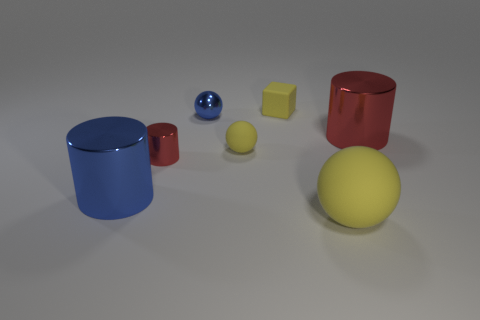Subtract all matte balls. How many balls are left? 1 Add 1 matte cubes. How many objects exist? 8 Subtract all yellow balls. How many balls are left? 1 Add 7 large yellow metal blocks. How many large yellow metal blocks exist? 7 Subtract 0 purple blocks. How many objects are left? 7 Subtract all spheres. How many objects are left? 4 Subtract 3 balls. How many balls are left? 0 Subtract all green cubes. Subtract all blue balls. How many cubes are left? 1 Subtract all purple balls. How many red cylinders are left? 2 Subtract all yellow balls. Subtract all big red shiny things. How many objects are left? 4 